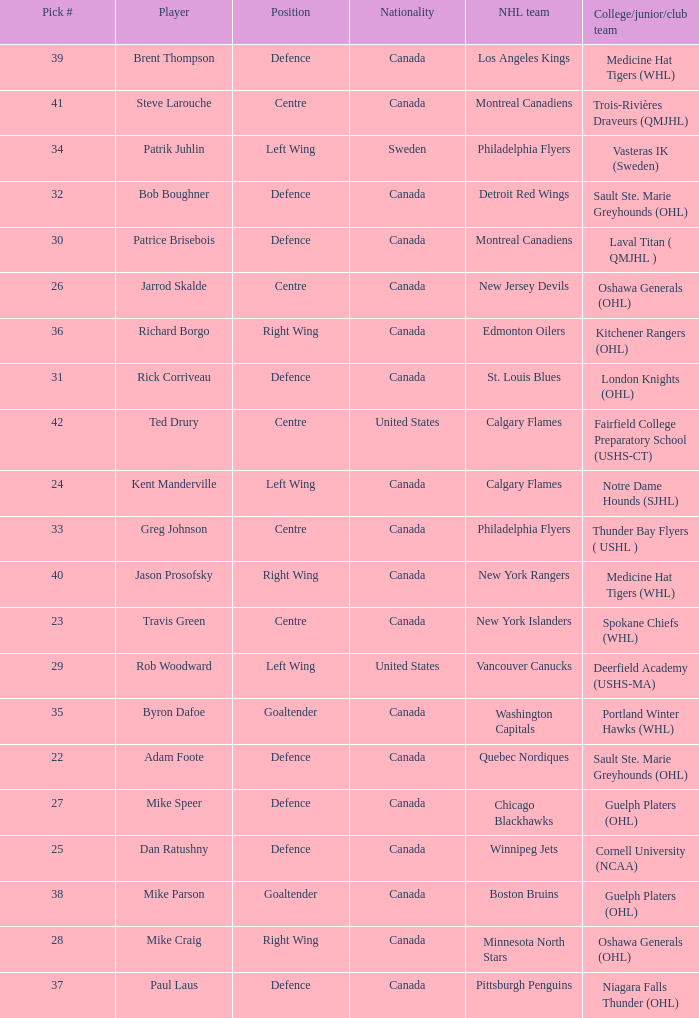What is the nationality of the player picked to go to Washington Capitals? Canada. 